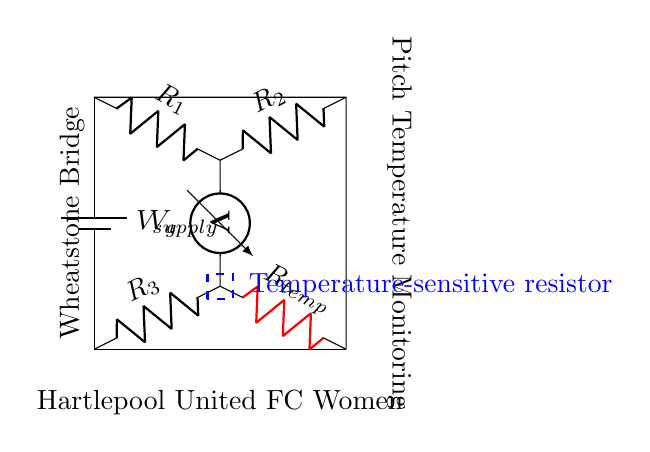What components are in the Wheatstone bridge? The components present are three resistors (R1, R2, R3) and a temperature-sensitive resistor (Rtemp), along with a battery and a voltmeter.
Answer: R1, R2, R3, Rtemp, battery, voltmeter What is the role of Rtemp in this circuit? Rtemp is a temperature-sensitive resistor that changes resistance based on temperature, allowing the bridge to measure pitch temperature by altering the balance in the circuit.
Answer: Temperature measurement What is connected across the voltmeter? The voltmeter is connected between the junctions of R1 and R2 and R3 and Rtemp, measuring the voltage difference indicating the balance of the circuit.
Answer: The junctions of R1, R2, R3, and Rtemp Which way does the current flow from the power supply? The current flows from the positive side of the power supply (battery) through R1 down to R2, then through the resistor network towards ground.
Answer: From positive to ground through resistors How does the Wheatstone bridge detect changes in temperature? The Wheatstone bridge detects changes in temperature by measuring the voltage (Vg) at the voltmeter, which indicates an imbalance in the bridge due to changes in Rtemp as temperature changes.
Answer: Through voltage measurement What is the essential concept behind the Wheatstone bridge operation? The essential concept is that the bridge is balanced when the ratio of resistances is equal; any change in Rtemp disrupts this balance, allowing detection of the temperature changes.
Answer: Balance of resistances 